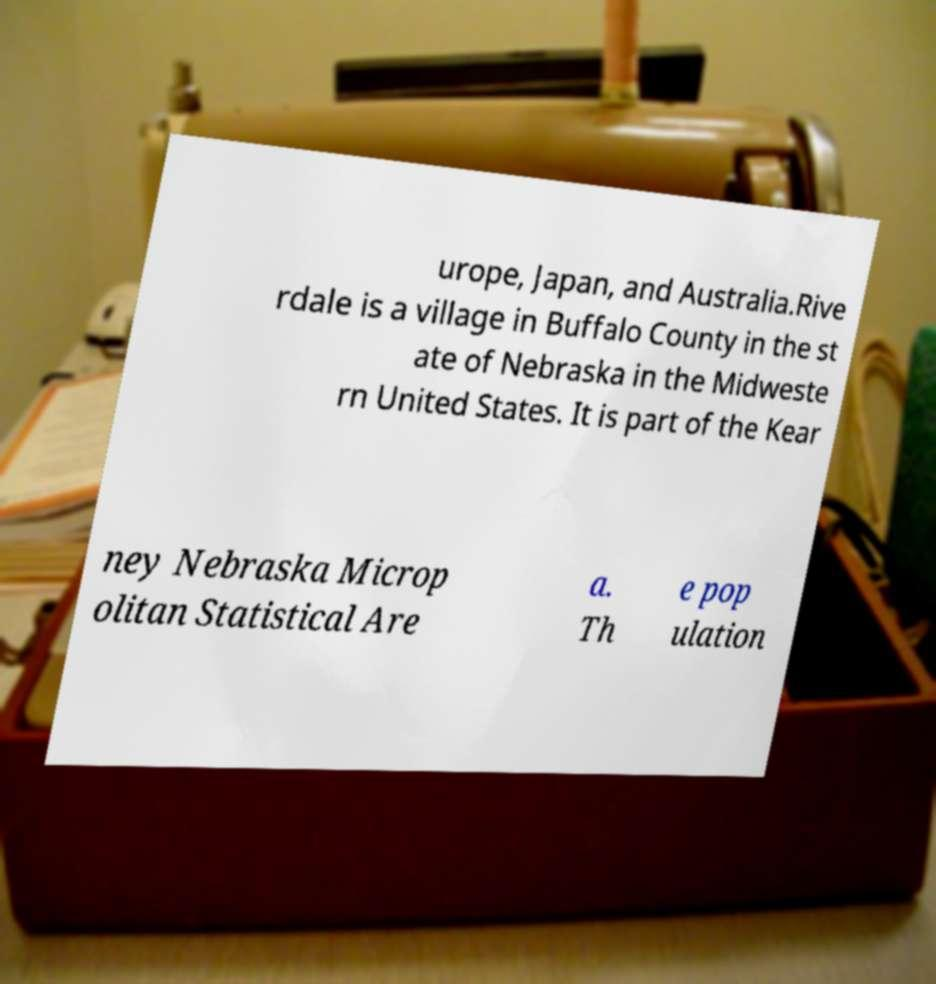There's text embedded in this image that I need extracted. Can you transcribe it verbatim? urope, Japan, and Australia.Rive rdale is a village in Buffalo County in the st ate of Nebraska in the Midweste rn United States. It is part of the Kear ney Nebraska Microp olitan Statistical Are a. Th e pop ulation 